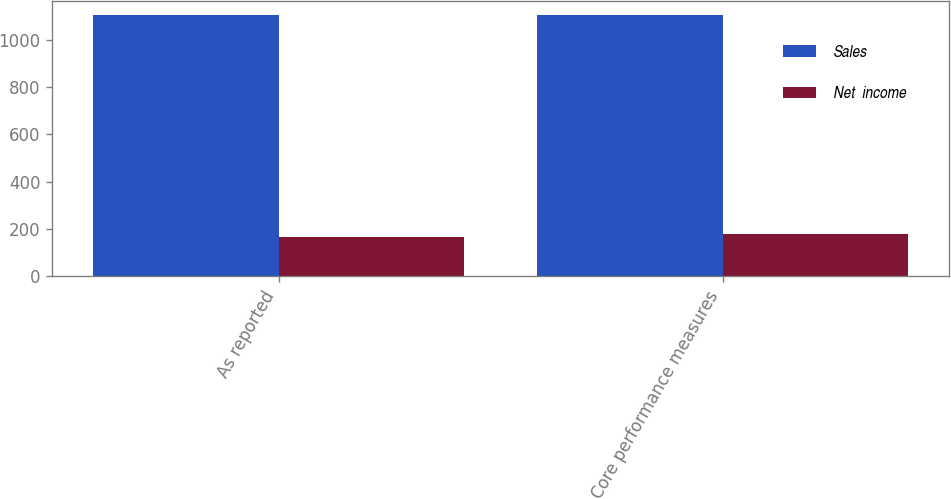<chart> <loc_0><loc_0><loc_500><loc_500><stacked_bar_chart><ecel><fcel>As reported<fcel>Core performance measures<nl><fcel>Sales<fcel>1107<fcel>1107<nl><fcel>Net  income<fcel>167<fcel>178<nl></chart> 